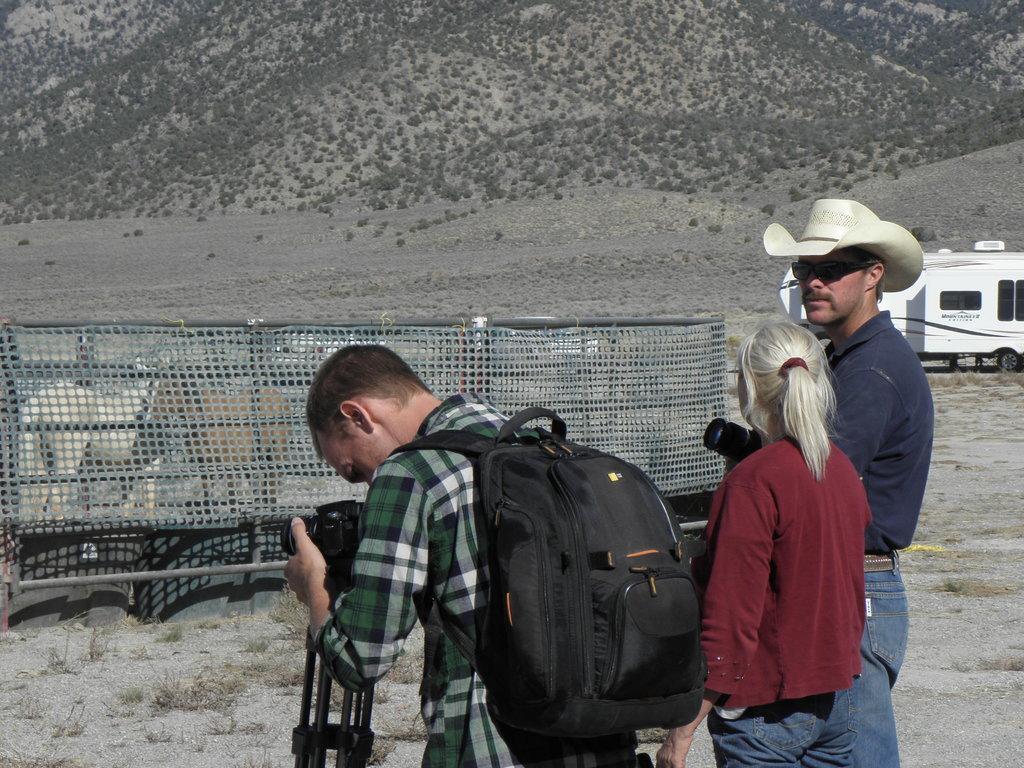Could you give a brief overview of what you see in this image? in this image i can see 3 people. the person at the left is wearing green color shirt with a black color backpack. he is holding a camera and a tripod. the person at the center is wearing maroon t shirt. the person at the right is wearing blue t shirt and cream hat. behind them there is a vehicle and trees and mountains. 